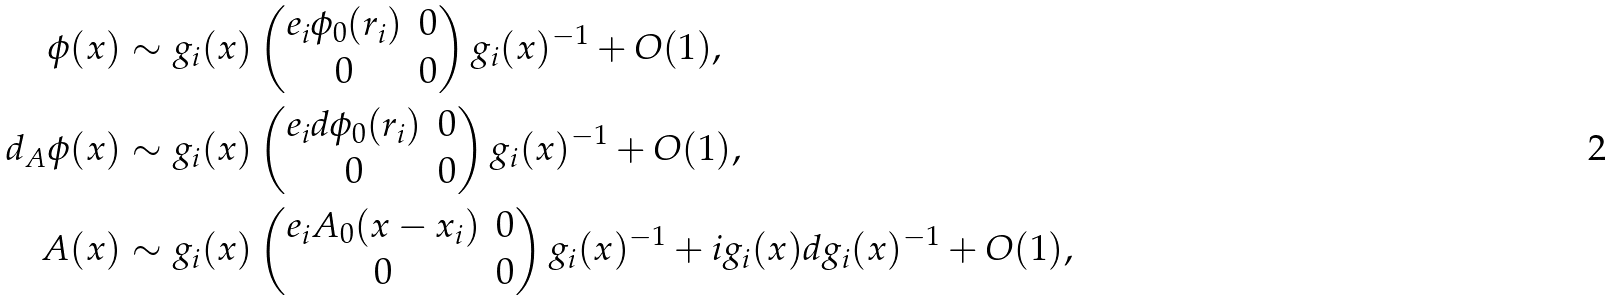<formula> <loc_0><loc_0><loc_500><loc_500>\phi ( x ) & \sim g _ { i } ( x ) \begin{pmatrix} e _ { i } \phi _ { 0 } ( r _ { i } ) & 0 \\ 0 & 0 \end{pmatrix} g _ { i } ( x ) ^ { - 1 } + O ( 1 ) , \\ d _ { A } \phi ( x ) & \sim g _ { i } ( x ) \begin{pmatrix} e _ { i } d \phi _ { 0 } ( r _ { i } ) & 0 \\ 0 & 0 \end{pmatrix} g _ { i } ( x ) ^ { - 1 } + O ( 1 ) , \\ A ( x ) & \sim g _ { i } ( x ) \begin{pmatrix} e _ { i } A _ { 0 } ( x - x _ { i } ) & 0 \\ 0 & 0 \end{pmatrix} g _ { i } ( x ) ^ { - 1 } + i g _ { i } ( x ) d g _ { i } ( x ) ^ { - 1 } + O ( 1 ) ,</formula> 